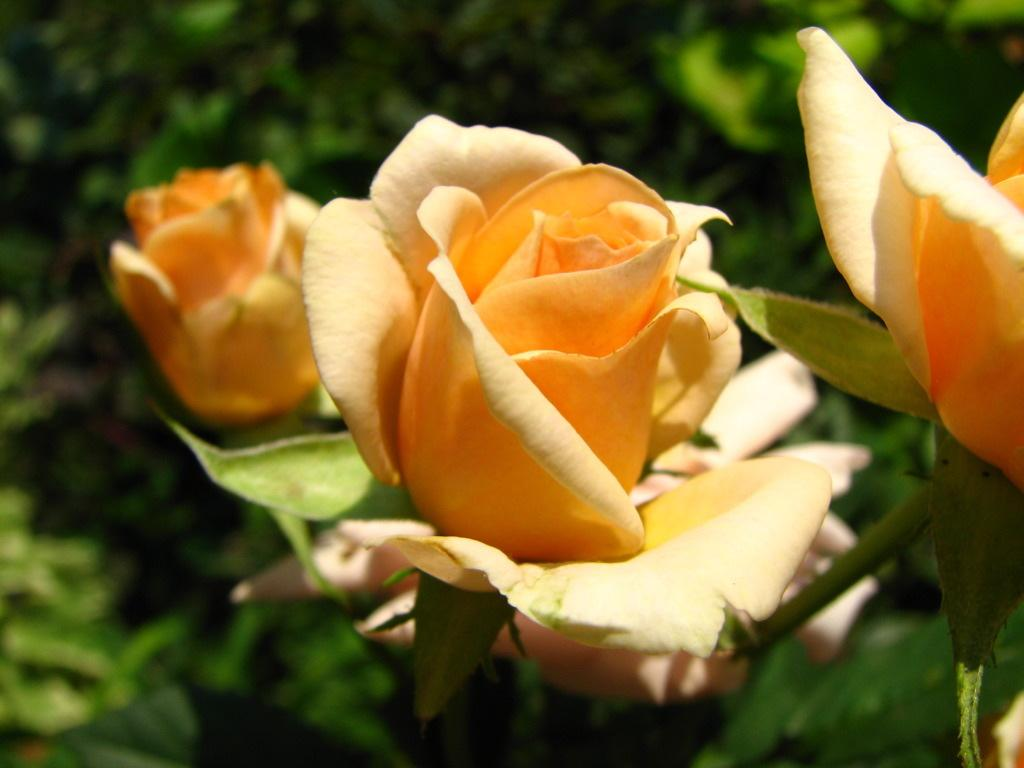What type of living organisms can be seen in the image? There are flowers in the image. Can you describe the background of the image? The background of the image is blurred. What type of stove is visible in the image? There is no stove present in the image. Can you tell me how many people are depicted in the image? There are no people depicted in the image. What type of prose is written on the flowers in the image? There is no prose written on the flowers in the image; they are simply depicted as living organisms. 